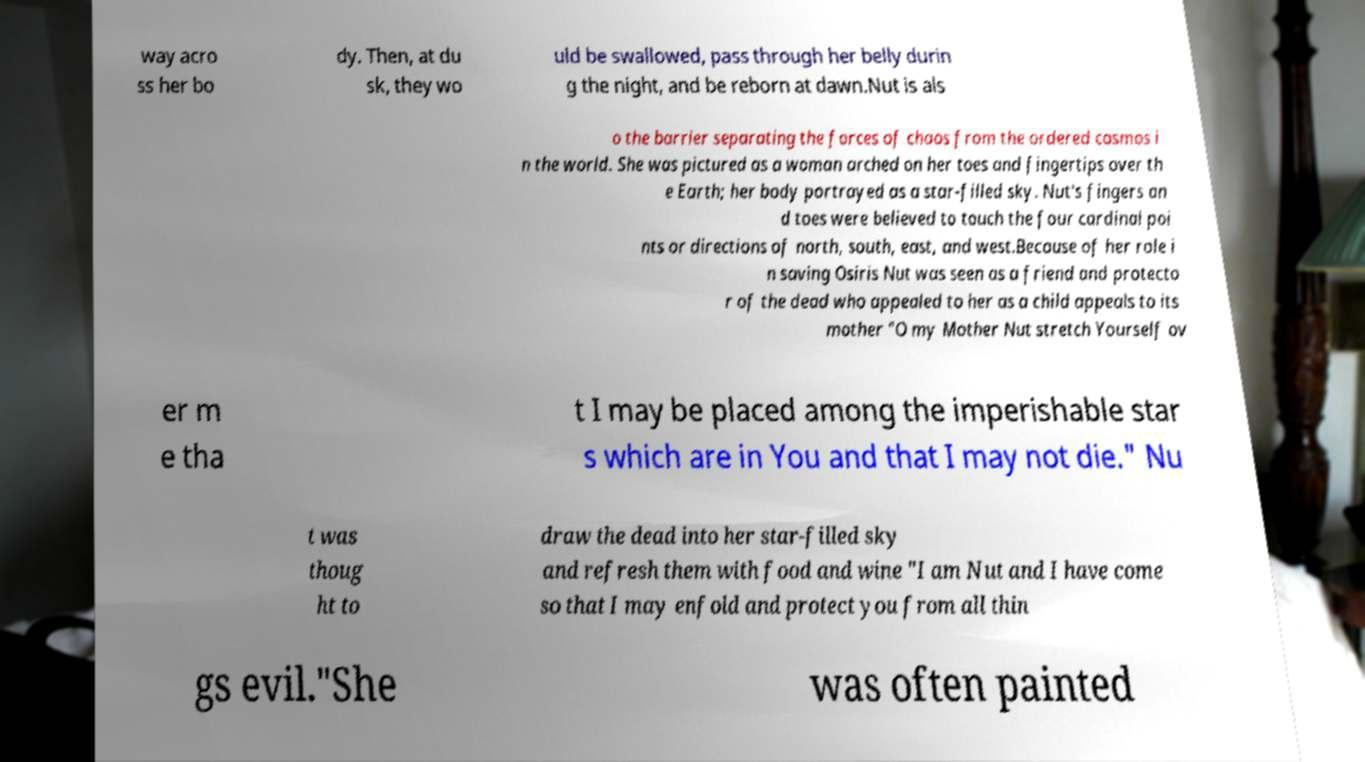What messages or text are displayed in this image? I need them in a readable, typed format. way acro ss her bo dy. Then, at du sk, they wo uld be swallowed, pass through her belly durin g the night, and be reborn at dawn.Nut is als o the barrier separating the forces of chaos from the ordered cosmos i n the world. She was pictured as a woman arched on her toes and fingertips over th e Earth; her body portrayed as a star-filled sky. Nut's fingers an d toes were believed to touch the four cardinal poi nts or directions of north, south, east, and west.Because of her role i n saving Osiris Nut was seen as a friend and protecto r of the dead who appealed to her as a child appeals to its mother "O my Mother Nut stretch Yourself ov er m e tha t I may be placed among the imperishable star s which are in You and that I may not die." Nu t was thoug ht to draw the dead into her star-filled sky and refresh them with food and wine "I am Nut and I have come so that I may enfold and protect you from all thin gs evil."She was often painted 